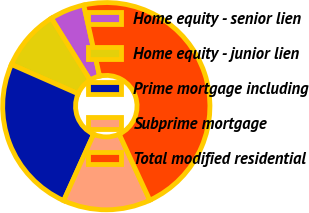Convert chart. <chart><loc_0><loc_0><loc_500><loc_500><pie_chart><fcel>Home equity - senior lien<fcel>Home equity - junior lien<fcel>Prime mortgage including<fcel>Subprime mortgage<fcel>Total modified residential<nl><fcel>5.4%<fcel>9.52%<fcel>24.85%<fcel>13.64%<fcel>46.6%<nl></chart> 